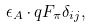Convert formula to latex. <formula><loc_0><loc_0><loc_500><loc_500>\epsilon _ { A } \cdot q F _ { \pi } \delta _ { i j } ,</formula> 